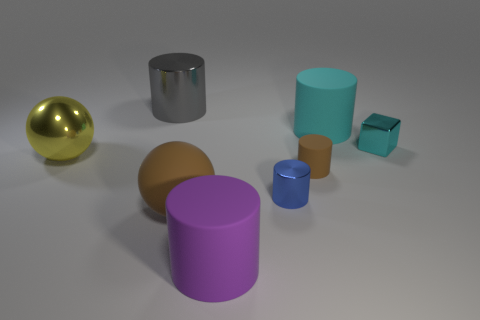Subtract all big rubber cylinders. How many cylinders are left? 3 Subtract all purple cylinders. How many cylinders are left? 4 Add 1 blue objects. How many objects exist? 9 Subtract all brown cylinders. Subtract all blue blocks. How many cylinders are left? 4 Subtract all cubes. How many objects are left? 7 Add 7 yellow things. How many yellow things are left? 8 Add 4 small cyan matte objects. How many small cyan matte objects exist? 4 Subtract 1 blue cylinders. How many objects are left? 7 Subtract all gray spheres. Subtract all brown rubber spheres. How many objects are left? 7 